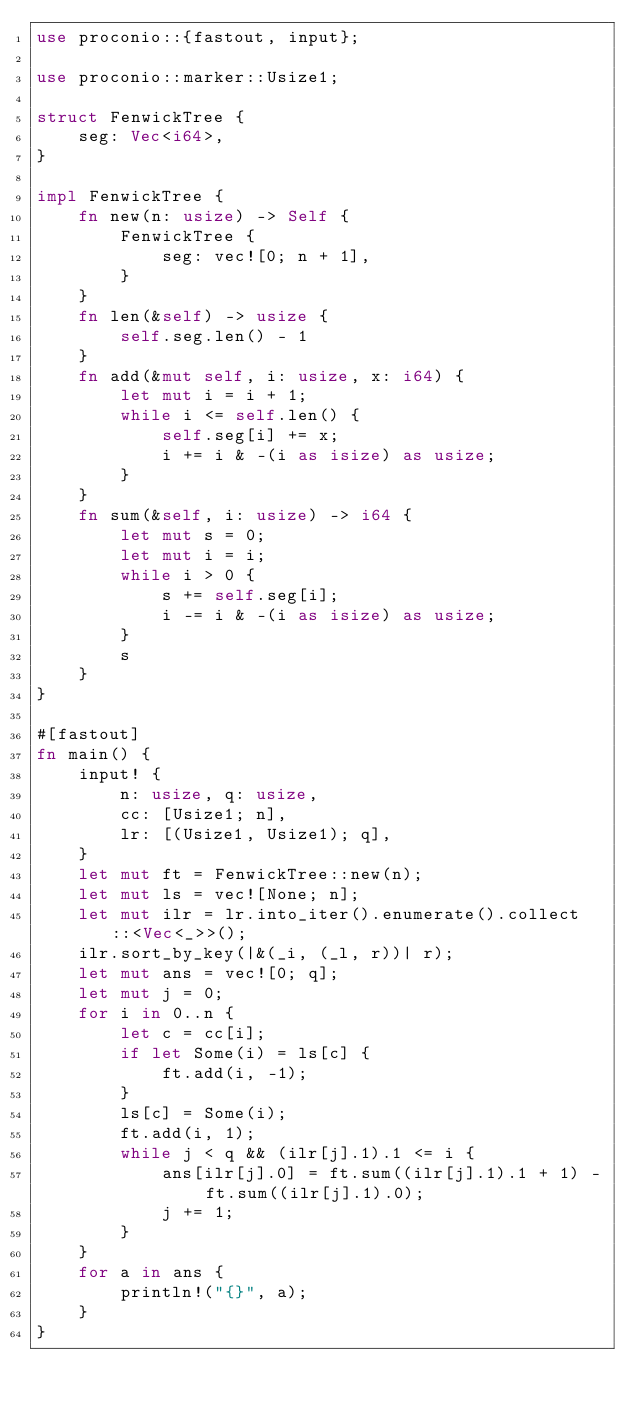Convert code to text. <code><loc_0><loc_0><loc_500><loc_500><_Rust_>use proconio::{fastout, input};

use proconio::marker::Usize1;

struct FenwickTree {
    seg: Vec<i64>,
}

impl FenwickTree {
    fn new(n: usize) -> Self {
        FenwickTree {
            seg: vec![0; n + 1],
        }
    }
    fn len(&self) -> usize {
        self.seg.len() - 1
    }
    fn add(&mut self, i: usize, x: i64) {
        let mut i = i + 1;
        while i <= self.len() {
            self.seg[i] += x;
            i += i & -(i as isize) as usize;
        }
    }
    fn sum(&self, i: usize) -> i64 {
        let mut s = 0;
        let mut i = i;
        while i > 0 {
            s += self.seg[i];
            i -= i & -(i as isize) as usize;
        }
        s
    }
}

#[fastout]
fn main() {
    input! {
        n: usize, q: usize,
        cc: [Usize1; n],
        lr: [(Usize1, Usize1); q],
    }
    let mut ft = FenwickTree::new(n);
    let mut ls = vec![None; n];
    let mut ilr = lr.into_iter().enumerate().collect::<Vec<_>>();
    ilr.sort_by_key(|&(_i, (_l, r))| r);
    let mut ans = vec![0; q];
    let mut j = 0;
    for i in 0..n {
        let c = cc[i];
        if let Some(i) = ls[c] {
            ft.add(i, -1);
        }
        ls[c] = Some(i);
        ft.add(i, 1);
        while j < q && (ilr[j].1).1 <= i {
            ans[ilr[j].0] = ft.sum((ilr[j].1).1 + 1) - ft.sum((ilr[j].1).0);
            j += 1;
        }
    }
    for a in ans {
        println!("{}", a);
    }
}
</code> 